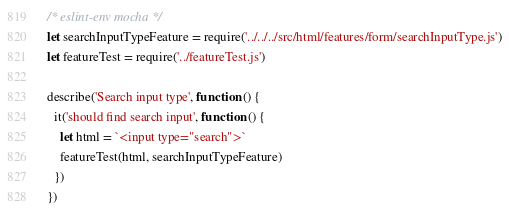<code> <loc_0><loc_0><loc_500><loc_500><_JavaScript_>/* eslint-env mocha */
let searchInputTypeFeature = require('../../../src/html/features/form/searchInputType.js')
let featureTest = require('../featureTest.js')

describe('Search input type', function () {
  it('should find search input', function () {
    let html = `<input type="search">`
    featureTest(html, searchInputTypeFeature)
  })
})
</code> 